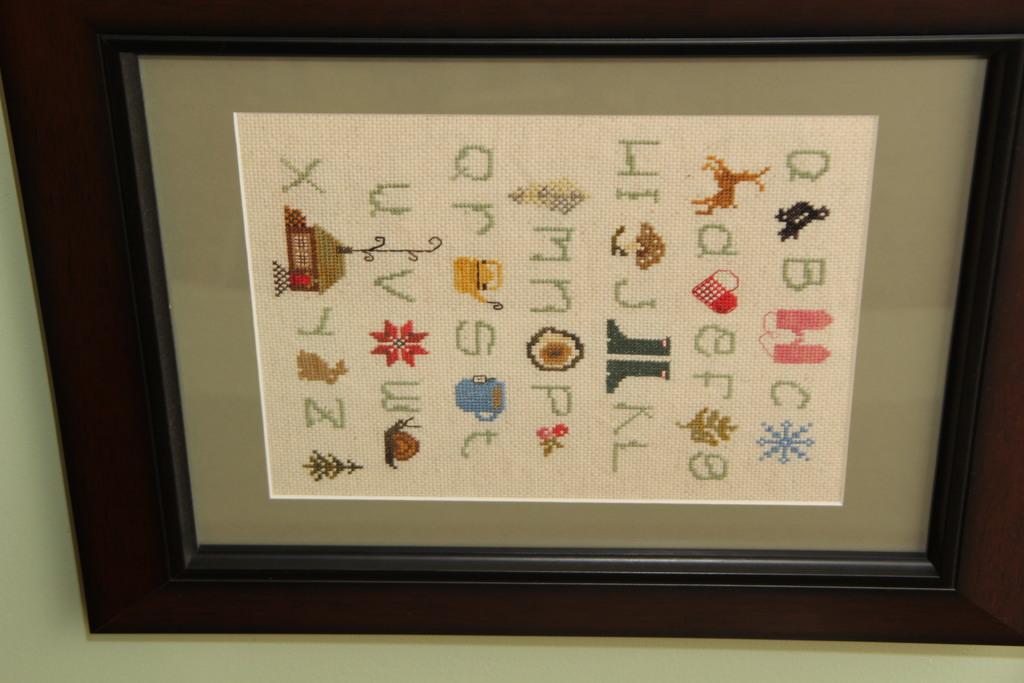 what is on this framed picture?
Your answer should be compact. Abcdefghijklmnopqrstuvwxyz. What is the first letter on the picture?
Provide a succinct answer. A. 